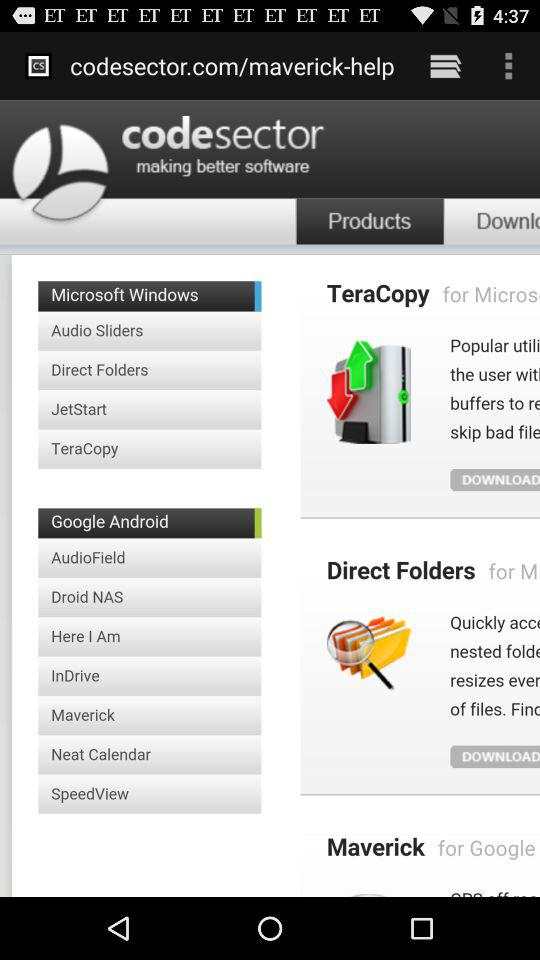What is the application name? The application name is "codesector". 